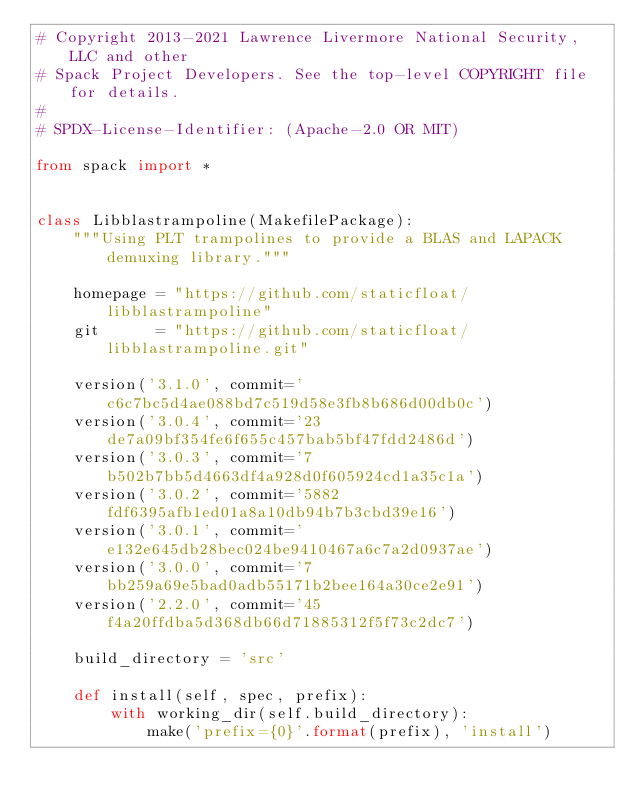Convert code to text. <code><loc_0><loc_0><loc_500><loc_500><_Python_># Copyright 2013-2021 Lawrence Livermore National Security, LLC and other
# Spack Project Developers. See the top-level COPYRIGHT file for details.
#
# SPDX-License-Identifier: (Apache-2.0 OR MIT)

from spack import *


class Libblastrampoline(MakefilePackage):
    """Using PLT trampolines to provide a BLAS and LAPACK demuxing library."""

    homepage = "https://github.com/staticfloat/libblastrampoline"
    git      = "https://github.com/staticfloat/libblastrampoline.git"

    version('3.1.0', commit='c6c7bc5d4ae088bd7c519d58e3fb8b686d00db0c')
    version('3.0.4', commit='23de7a09bf354fe6f655c457bab5bf47fdd2486d')
    version('3.0.3', commit='7b502b7bb5d4663df4a928d0f605924cd1a35c1a')
    version('3.0.2', commit='5882fdf6395afb1ed01a8a10db94b7b3cbd39e16')
    version('3.0.1', commit='e132e645db28bec024be9410467a6c7a2d0937ae')
    version('3.0.0', commit='7bb259a69e5bad0adb55171b2bee164a30ce2e91')
    version('2.2.0', commit='45f4a20ffdba5d368db66d71885312f5f73c2dc7')

    build_directory = 'src'

    def install(self, spec, prefix):
        with working_dir(self.build_directory):
            make('prefix={0}'.format(prefix), 'install')
</code> 